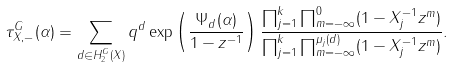Convert formula to latex. <formula><loc_0><loc_0><loc_500><loc_500>\tau _ { X , - } ^ { G } ( \alpha ) = \sum _ { d \in H _ { 2 } ^ { G } ( X ) } q ^ { d } \exp \left ( \frac { \Psi _ { d } ( \alpha ) } { 1 - { z } ^ { - 1 } } \right ) \frac { \prod _ { j = 1 } ^ { k } \prod _ { m = - \infty } ^ { 0 } ( 1 - X _ { j } ^ { - 1 } { z } ^ { m } ) } { \prod _ { j = 1 } ^ { k } \prod _ { m = - \infty } ^ { \mu _ { j } ( d ) } ( 1 - X _ { j } ^ { - 1 } { z } ^ { m } ) } .</formula> 